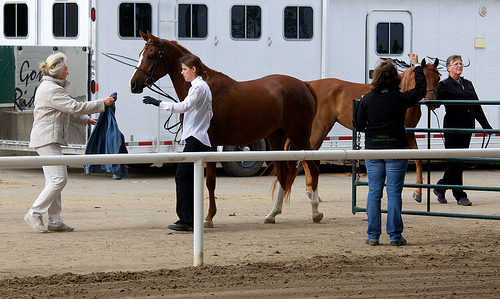<image>
Can you confirm if the horse is behind the ground? No. The horse is not behind the ground. From this viewpoint, the horse appears to be positioned elsewhere in the scene. Where is the window in relation to the horse? Is it next to the horse? Yes. The window is positioned adjacent to the horse, located nearby in the same general area. Where is the horse in relation to the person? Is it in front of the person? No. The horse is not in front of the person. The spatial positioning shows a different relationship between these objects. 